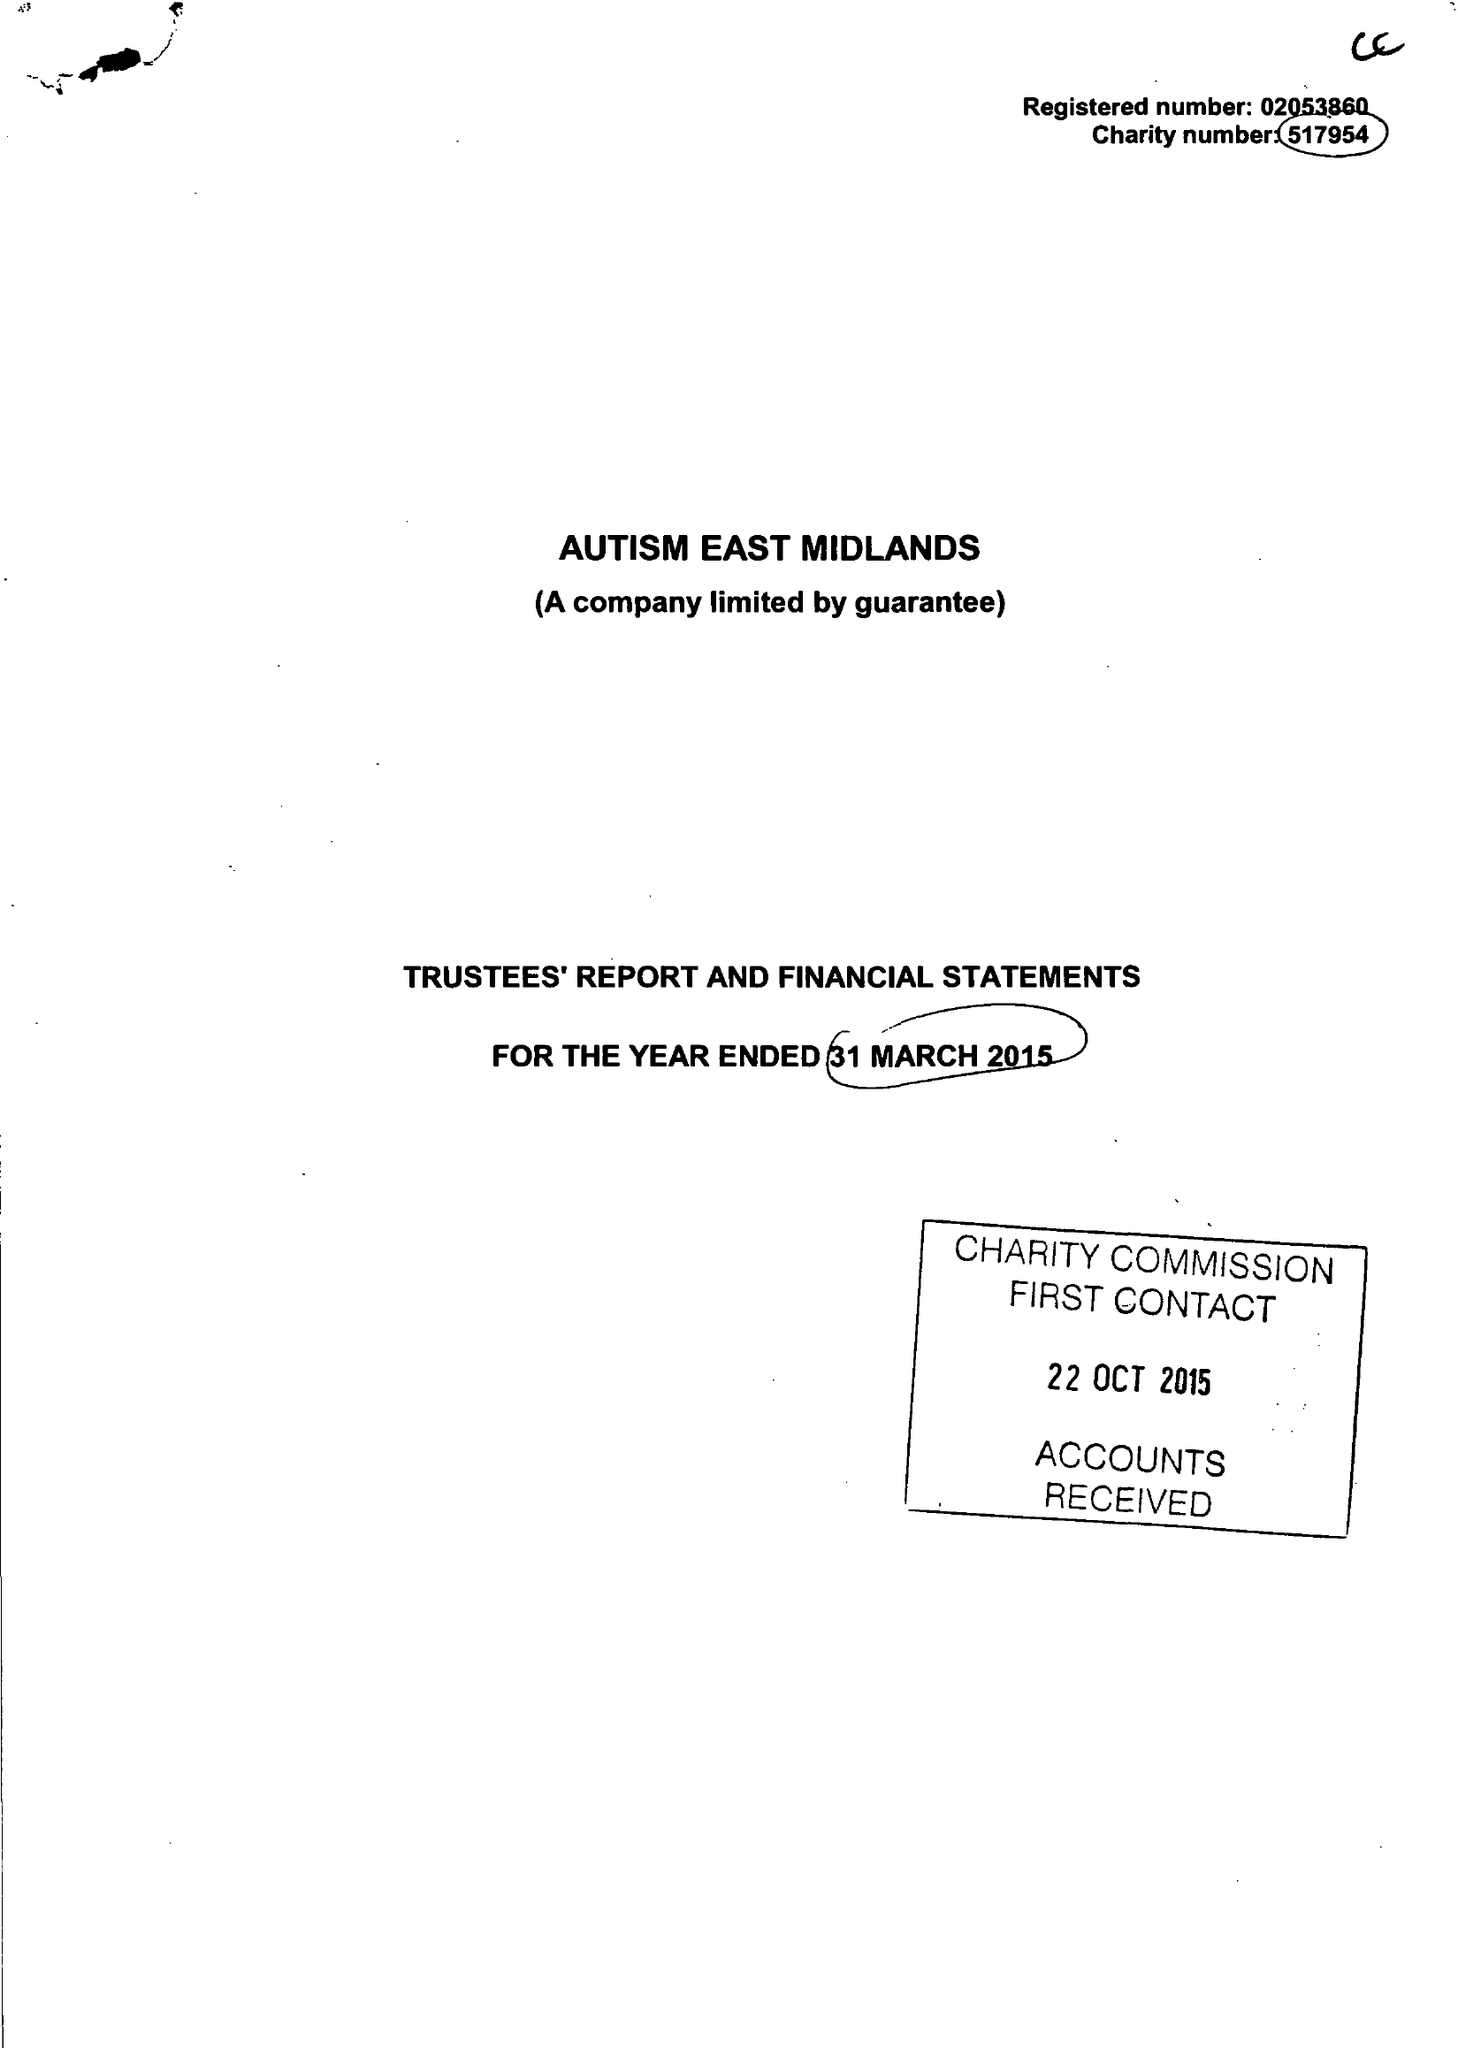What is the value for the report_date?
Answer the question using a single word or phrase. 2015-03-31 